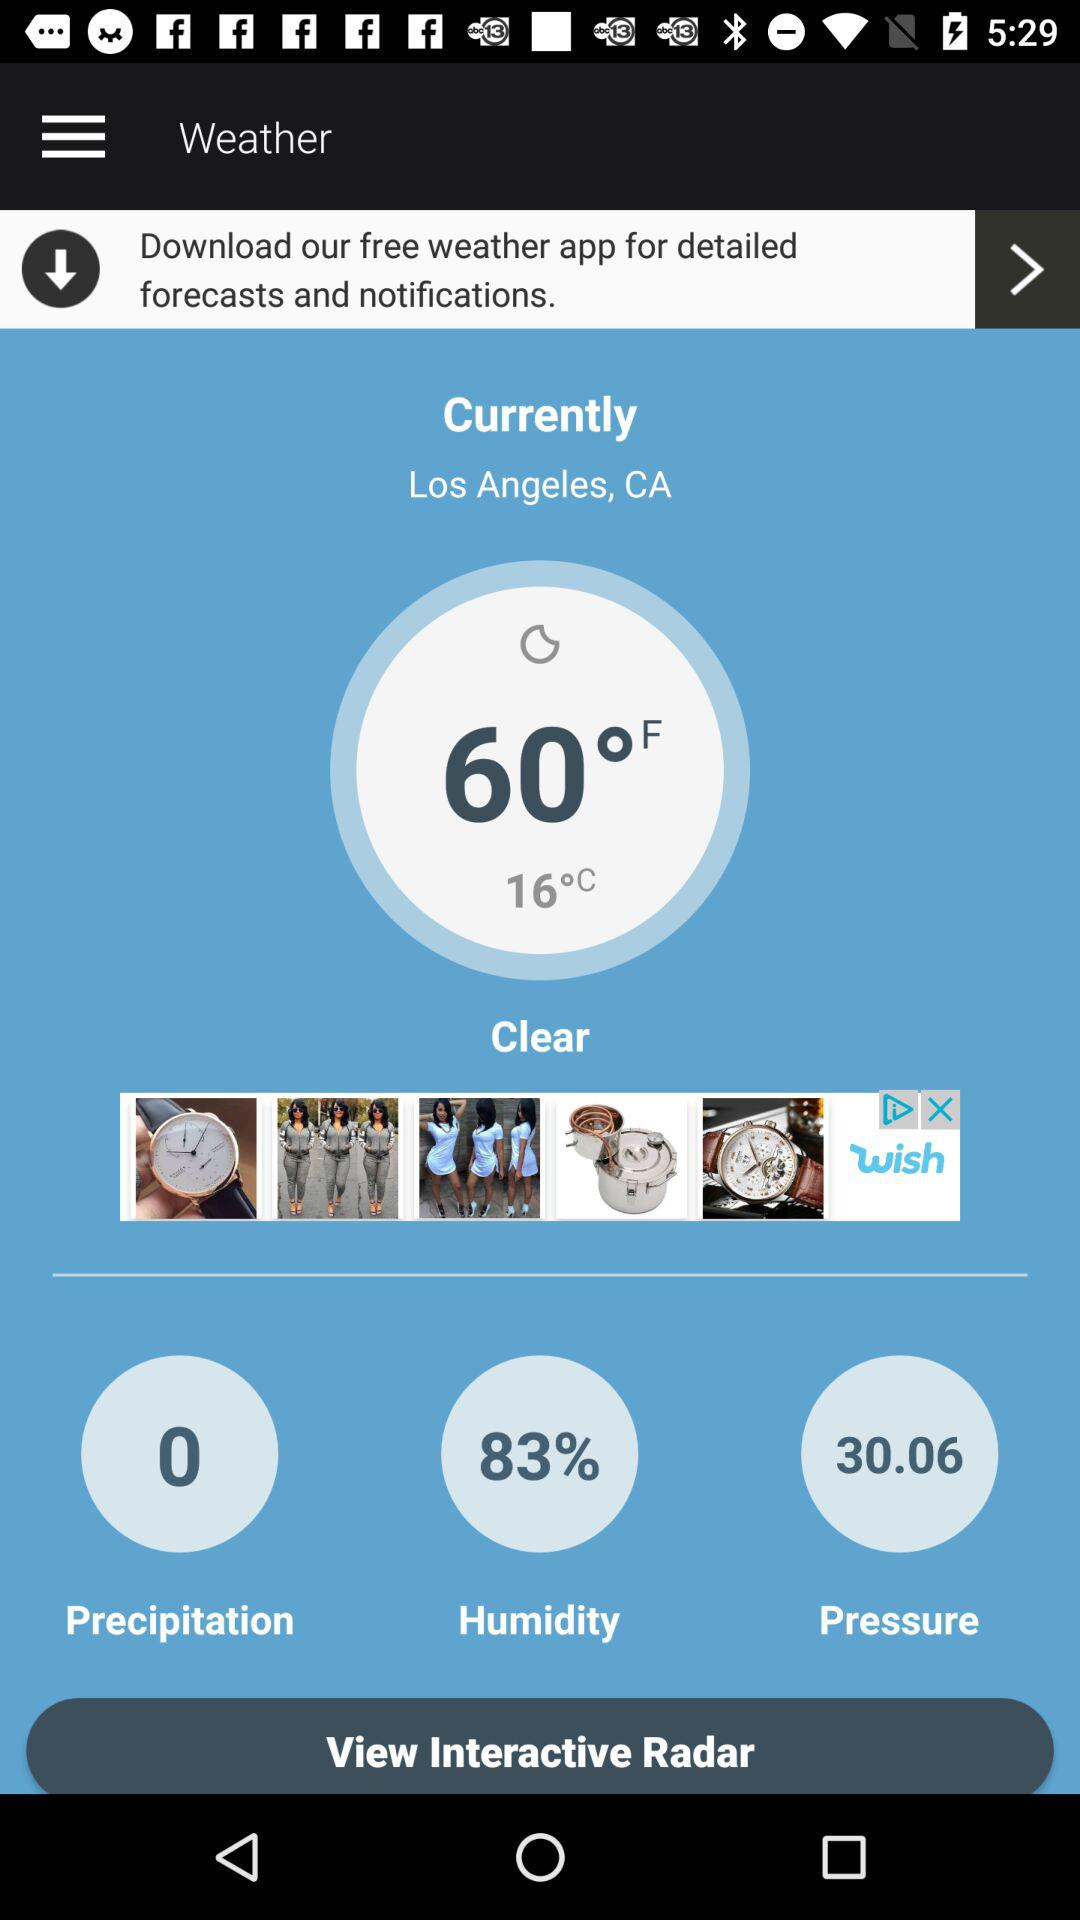What is the temperature? The temperature is 60 °F (16 °C). 